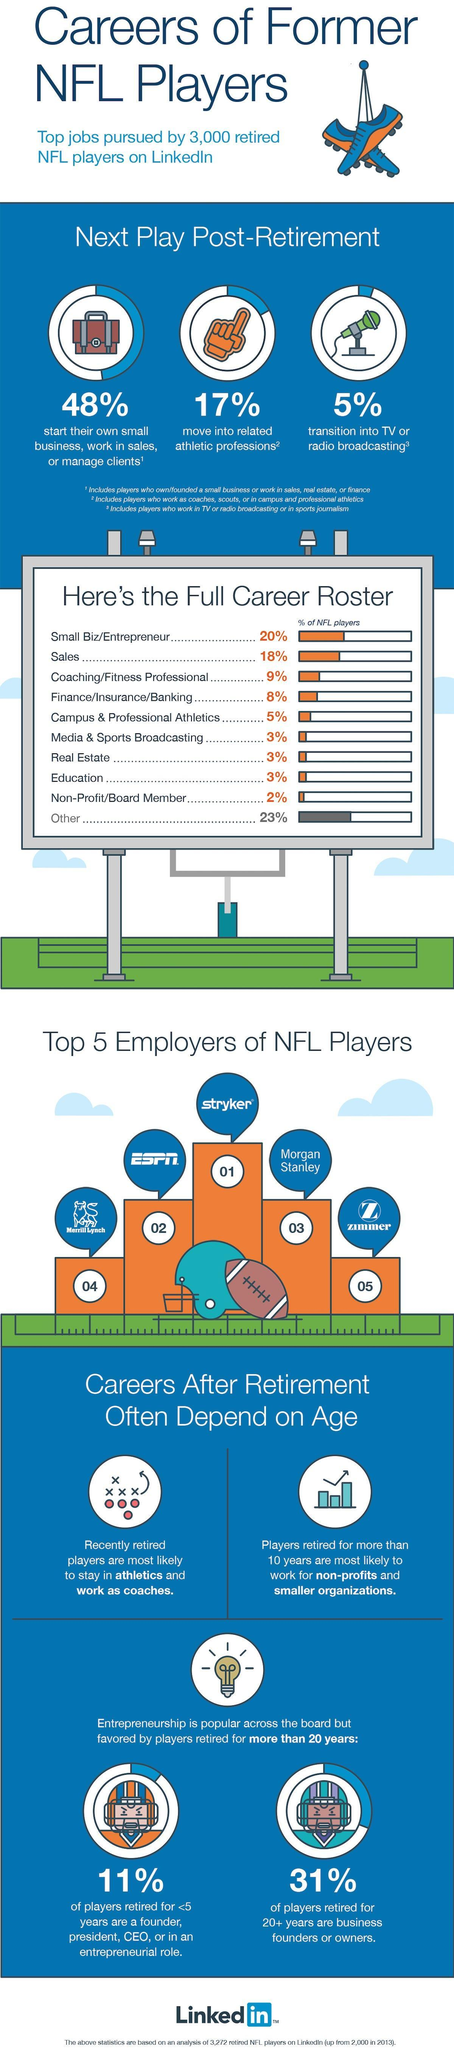What percentage of NFL players start their own small business, work in sales or manage clients in post-retirement?
Answer the question with a short phrase. 48% What percentage of NFL players move into media & sports broadcasting after the retirement? 3% What percentage of NFL players move into related athletic professions in post-retirement? 17% Who is the top employer on LinkedIn for former NFL players? Stryker What percentage of NFL players retired for 20+ years are business founders or owners? 31% 